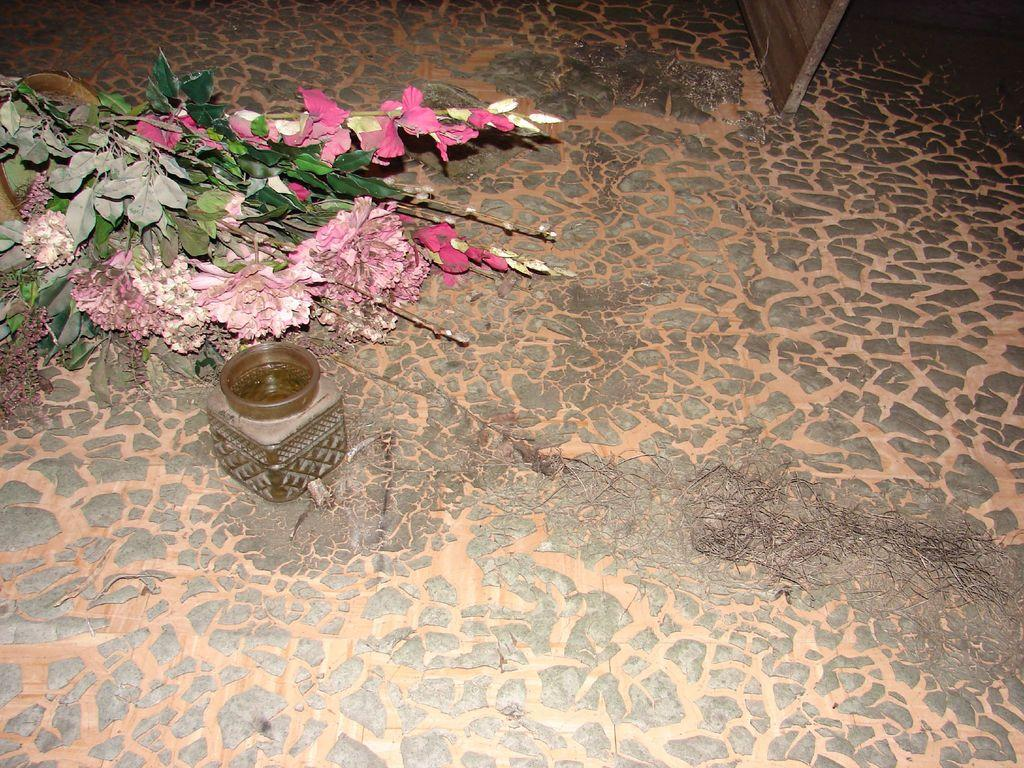What types of living organisms can be seen in the image? Plants and flowers are visible in the image. Can you describe the jar in the image? Yes, there is a jar on the surface in the image. What type of pancake is being served in the image? There is no pancake present in the image; it features plants, flowers, and a jar. What material is the jar made of in the image? The material of the jar is not mentioned in the image, so it cannot be determined. 